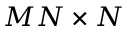<formula> <loc_0><loc_0><loc_500><loc_500>M N \times N</formula> 